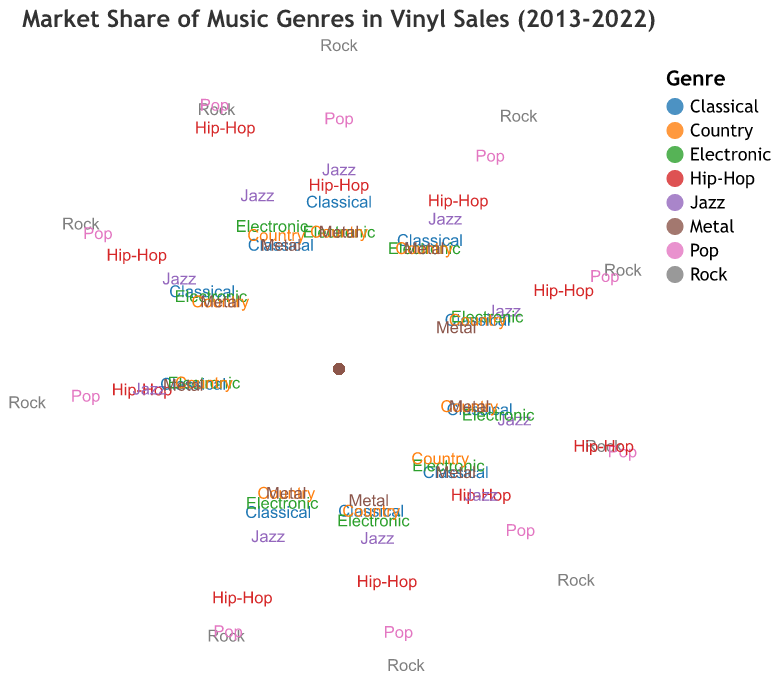What's the title of the Polar Chart? The title is clearly displayed at the top of the Polar Chart.
Answer: Market Share of Music Genres in Vinyl Sales (2013-2022) Which genre had the highest market share in 2013? By looking at the data points around the circle for the year 2013, the largest radius corresponds to Rock.
Answer: Rock How did the market share of Hip-Hop change from 2013 to 2022? Starting from the point on the circle representing 2013 to the point for 2022, you can see that Hip-Hop has increased, shown by the radius expanding from 10 to 25.
Answer: Increased In which year did Pop have a higher market share than Rock, for the first time? Comparing the points for Pop and Rock year by year, Pop surpasses Rock in market share in 2021 for the first time.
Answer: 2021 What was the trend of Jazz market share from 2013 to 2022? Observing Jazz's radius points over the years, the radius doesn't show a significant trend up or down but slightly fluctuates around 10.
Answer: Fluctuated slightly Which two genres had a constant market share in some years and how did it change over time? By observing the changes over time, Country and Metal show a constant market share in several years, specifically at 5% sometimes, then fluctuate slightly in other years.
Answer: Country and Metal, and it fluctuated slightly How does the radius represent the value in this Polar Chart? The radius corresponds to the market share percentage, with larger radii indicating higher market shares.
Answer: Larger radii indicate higher market shares What was the total market share of Classical music over the entire decade? Summing up the market share of Classical from 2013 to 2022: 8 + 7 + 6 + 7 + 6 + 7 + 6 + 7 + 5 + 6 equals 65.
Answer: 65 Which genre had the most significant increase in market share from 2013 to 2022? By comparing the initial and final values for each genre, Hip-Hop shows the most significant increase, from 10 to 25.
Answer: Hip-Hop What color is used to represent the genre with the second highest market share in 2022? Observing the color scale and the corresponding genres, Pop, which is represented in shades of different colors from the category10 scale, is second in 2022.
Answer: It's represented by one of the category10 colors (identifiable based on the full-color scale) 